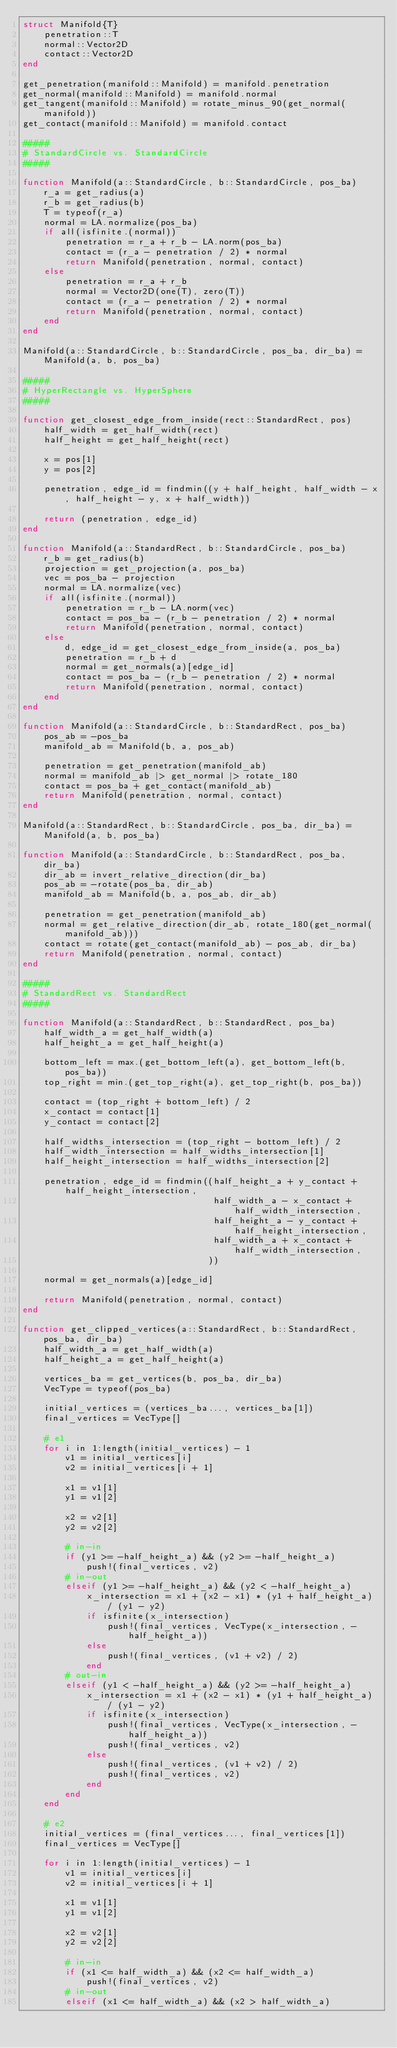<code> <loc_0><loc_0><loc_500><loc_500><_Julia_>struct Manifold{T}
    penetration::T
    normal::Vector2D
    contact::Vector2D
end

get_penetration(manifold::Manifold) = manifold.penetration
get_normal(manifold::Manifold) = manifold.normal
get_tangent(manifold::Manifold) = rotate_minus_90(get_normal(manifold))
get_contact(manifold::Manifold) = manifold.contact

#####
# StandardCircle vs. StandardCircle
#####

function Manifold(a::StandardCircle, b::StandardCircle, pos_ba)
    r_a = get_radius(a)
    r_b = get_radius(b)
    T = typeof(r_a)
    normal = LA.normalize(pos_ba)
    if all(isfinite.(normal))
        penetration = r_a + r_b - LA.norm(pos_ba)
        contact = (r_a - penetration / 2) * normal
        return Manifold(penetration, normal, contact)
    else
        penetration = r_a + r_b
        normal = Vector2D(one(T), zero(T))
        contact = (r_a - penetration / 2) * normal
        return Manifold(penetration, normal, contact)
    end
end

Manifold(a::StandardCircle, b::StandardCircle, pos_ba, dir_ba) = Manifold(a, b, pos_ba)

#####
# HyperRectangle vs. HyperSphere
#####

function get_closest_edge_from_inside(rect::StandardRect, pos)
    half_width = get_half_width(rect)
    half_height = get_half_height(rect)

    x = pos[1]
    y = pos[2]

    penetration, edge_id = findmin((y + half_height, half_width - x, half_height - y, x + half_width))

    return (penetration, edge_id)
end

function Manifold(a::StandardRect, b::StandardCircle, pos_ba)
    r_b = get_radius(b)
    projection = get_projection(a, pos_ba)
    vec = pos_ba - projection
    normal = LA.normalize(vec)
    if all(isfinite.(normal))
        penetration = r_b - LA.norm(vec)
        contact = pos_ba - (r_b - penetration / 2) * normal
        return Manifold(penetration, normal, contact)
    else
        d, edge_id = get_closest_edge_from_inside(a, pos_ba)
        penetration = r_b + d
        normal = get_normals(a)[edge_id]
        contact = pos_ba - (r_b - penetration / 2) * normal
        return Manifold(penetration, normal, contact)
    end
end

function Manifold(a::StandardCircle, b::StandardRect, pos_ba)
    pos_ab = -pos_ba
    manifold_ab = Manifold(b, a, pos_ab)

    penetration = get_penetration(manifold_ab)
    normal = manifold_ab |> get_normal |> rotate_180
    contact = pos_ba + get_contact(manifold_ab)
    return Manifold(penetration, normal, contact)
end

Manifold(a::StandardRect, b::StandardCircle, pos_ba, dir_ba) = Manifold(a, b, pos_ba)

function Manifold(a::StandardCircle, b::StandardRect, pos_ba, dir_ba)
    dir_ab = invert_relative_direction(dir_ba)
    pos_ab = -rotate(pos_ba, dir_ab)
    manifold_ab = Manifold(b, a, pos_ab, dir_ab)

    penetration = get_penetration(manifold_ab)
    normal = get_relative_direction(dir_ab, rotate_180(get_normal(manifold_ab)))
    contact = rotate(get_contact(manifold_ab) - pos_ab, dir_ba)
    return Manifold(penetration, normal, contact)
end

#####
# StandardRect vs. StandardRect
#####

function Manifold(a::StandardRect, b::StandardRect, pos_ba)
    half_width_a = get_half_width(a)
    half_height_a = get_half_height(a)

    bottom_left = max.(get_bottom_left(a), get_bottom_left(b, pos_ba))
    top_right = min.(get_top_right(a), get_top_right(b, pos_ba))

    contact = (top_right + bottom_left) / 2
    x_contact = contact[1]
    y_contact = contact[2]

    half_widths_intersection = (top_right - bottom_left) / 2
    half_width_intersection = half_widths_intersection[1]
    half_height_intersection = half_widths_intersection[2]

    penetration, edge_id = findmin((half_height_a + y_contact + half_height_intersection,
                                    half_width_a - x_contact + half_width_intersection,
                                    half_height_a - y_contact + half_height_intersection,
                                    half_width_a + x_contact + half_width_intersection,
                                   ))

    normal = get_normals(a)[edge_id]

    return Manifold(penetration, normal, contact)
end

function get_clipped_vertices(a::StandardRect, b::StandardRect, pos_ba, dir_ba)
    half_width_a = get_half_width(a)
    half_height_a = get_half_height(a)

    vertices_ba = get_vertices(b, pos_ba, dir_ba)
    VecType = typeof(pos_ba)

    initial_vertices = (vertices_ba..., vertices_ba[1])
    final_vertices = VecType[]

    # e1
    for i in 1:length(initial_vertices) - 1
        v1 = initial_vertices[i]
        v2 = initial_vertices[i + 1]

        x1 = v1[1]
        y1 = v1[2]

        x2 = v2[1]
        y2 = v2[2]

        # in-in
        if (y1 >= -half_height_a) && (y2 >= -half_height_a)
            push!(final_vertices, v2)
        # in-out
        elseif (y1 >= -half_height_a) && (y2 < -half_height_a)
            x_intersection = x1 + (x2 - x1) * (y1 + half_height_a) / (y1 - y2)
            if isfinite(x_intersection)
                push!(final_vertices, VecType(x_intersection, -half_height_a))
            else
                push!(final_vertices, (v1 + v2) / 2)
            end
        # out-in
        elseif (y1 < -half_height_a) && (y2 >= -half_height_a)
            x_intersection = x1 + (x2 - x1) * (y1 + half_height_a) / (y1 - y2)
            if isfinite(x_intersection)
                push!(final_vertices, VecType(x_intersection, -half_height_a))
                push!(final_vertices, v2)
            else
                push!(final_vertices, (v1 + v2) / 2)
                push!(final_vertices, v2)
            end
        end
    end

    # e2
    initial_vertices = (final_vertices..., final_vertices[1])
    final_vertices = VecType[]

    for i in 1:length(initial_vertices) - 1
        v1 = initial_vertices[i]
        v2 = initial_vertices[i + 1]

        x1 = v1[1]
        y1 = v1[2]

        x2 = v2[1]
        y2 = v2[2]

        # in-in
        if (x1 <= half_width_a) && (x2 <= half_width_a)
            push!(final_vertices, v2)
        # in-out
        elseif (x1 <= half_width_a) && (x2 > half_width_a)</code> 